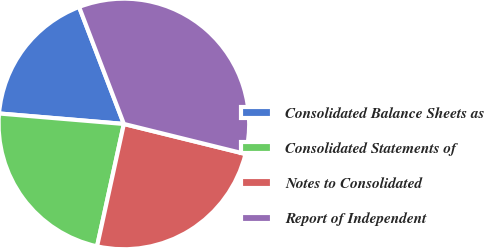<chart> <loc_0><loc_0><loc_500><loc_500><pie_chart><fcel>Consolidated Balance Sheets as<fcel>Consolidated Statements of<fcel>Notes to Consolidated<fcel>Report of Independent<nl><fcel>17.85%<fcel>22.9%<fcel>24.58%<fcel>34.67%<nl></chart> 